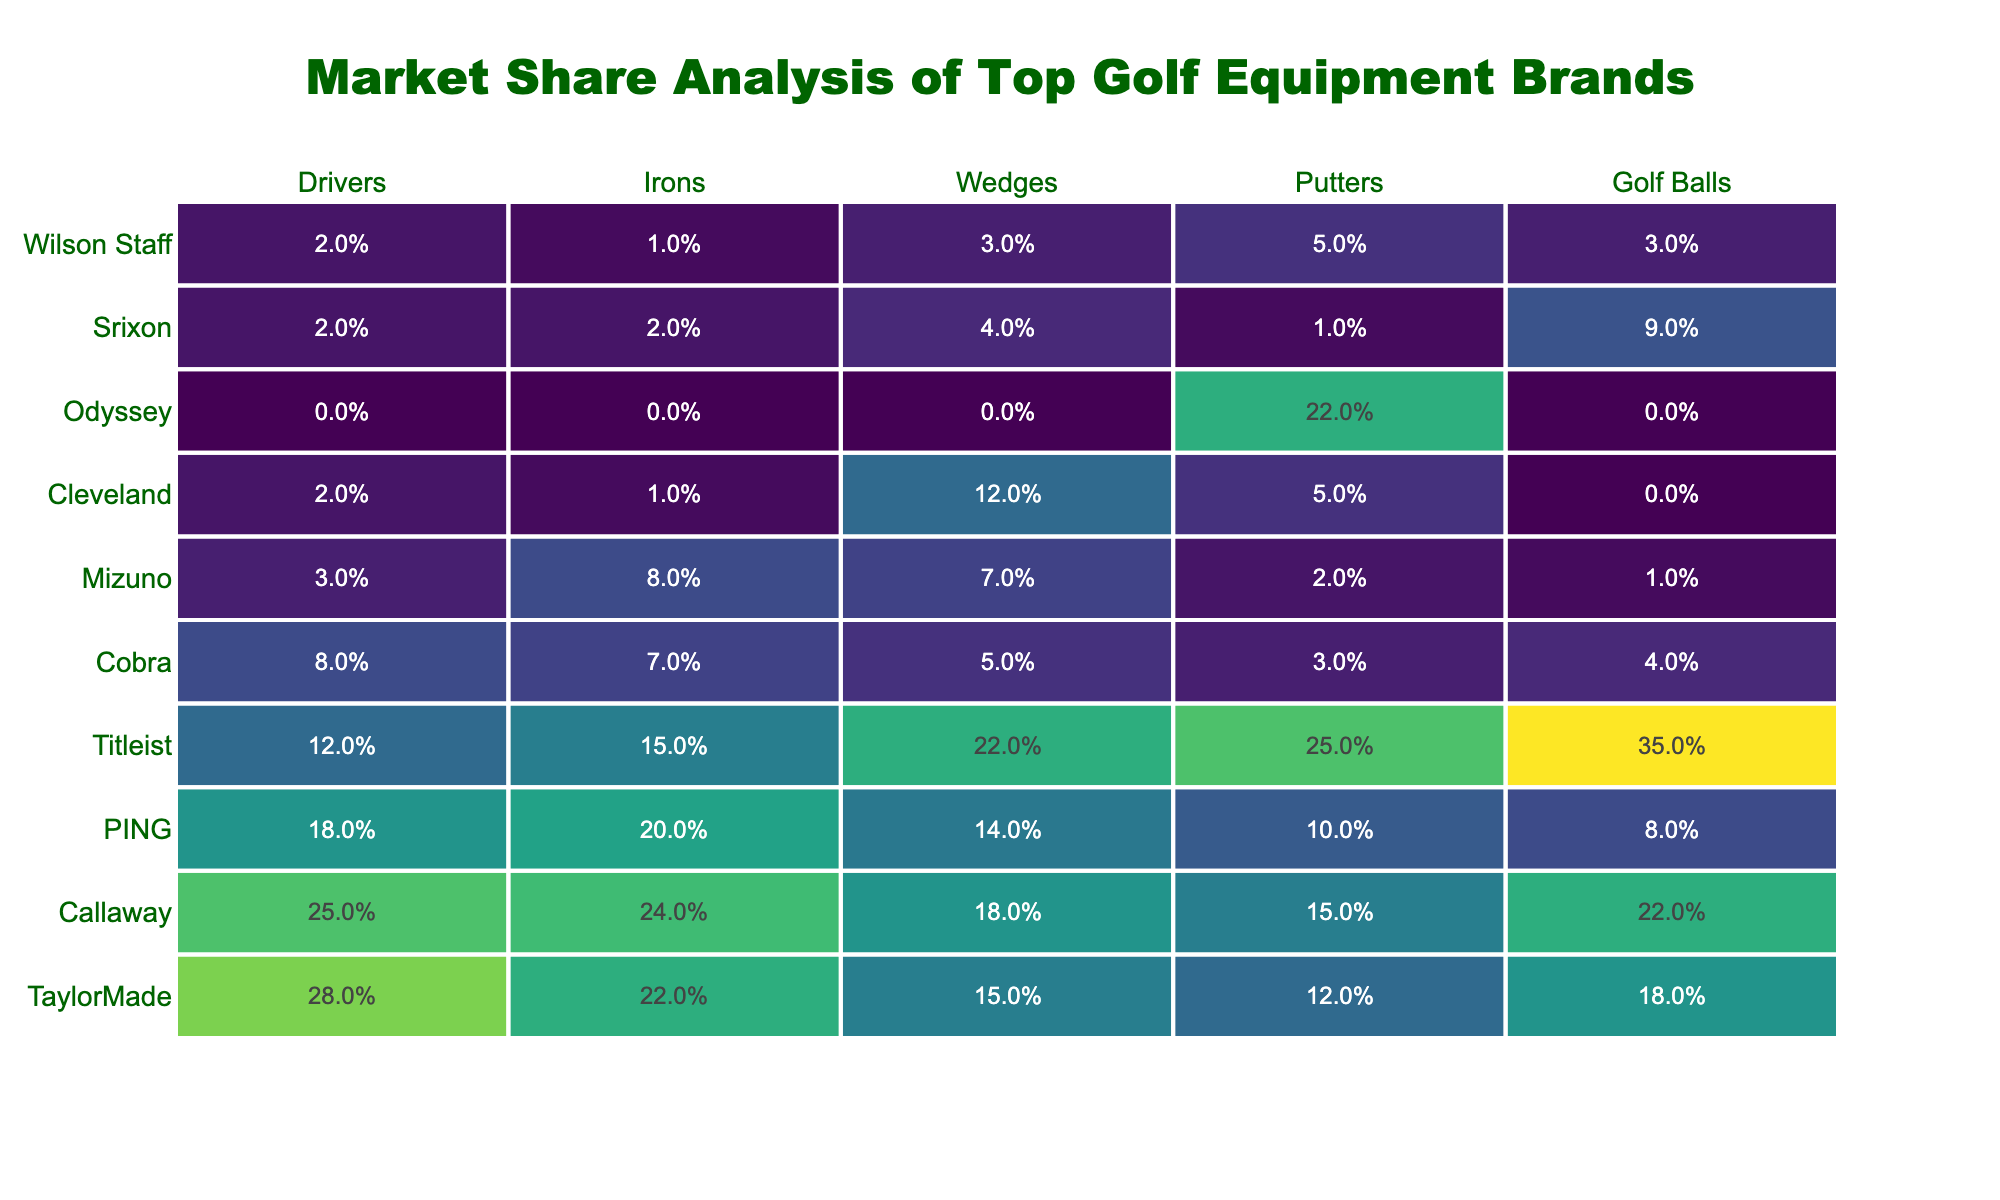What brand has the highest market share in Drivers? Looking at the "Drivers" column, TaylorMade has the highest percentage at 28%.
Answer: TaylorMade Which brand has the lowest market share for Wedges? In the "Wedges" column, Cobra has the lowest percentage at 5%.
Answer: Cobra What is the total market share for Callaway across all product categories? Summing the percentages for Callaway: 25% + 24% + 18% + 15% + 22% = 104%.
Answer: 104% Does Odyssey have any market share in Drivers? In the "Drivers" column, Odyssey's percentage is 0%, indicating it has no market share in this category.
Answer: No Which brand has the second highest market share in Golf Balls? The "Golf Balls" column shows Titleist at 35% and Callaway at 22%, making Callaway the second highest.
Answer: Callaway What percentage difference in market share exists between TaylorMade and PING in Irons? TaylorMade has 22% and PING has 20% in Irons. The difference is 22% - 20% = 2%.
Answer: 2% What is the average market share for all brands in Putters? The total for Putters is: 12% + 15% + 10% + 25% + 3% + 2% + 5% + 22% + 1% + 5% = 100%. There are 10 brands, so the average is 100% / 10 = 10%.
Answer: 10% Which product category has the highest market share for Titleist? The "Putters" column shows Titleist at 25%, which is its highest market share compared to other categories.
Answer: Putters Is there any brand that has zero market share in Golf Balls? In the "Golf Balls" column, Cleveland and Odyssey both show a percentage of 0%.
Answer: Yes Which brand has a higher market share in Irons, Callaway or Titleist? Callaway has 24% and Titleist has 15% in Irons. Callaway has the higher share.
Answer: Callaway 